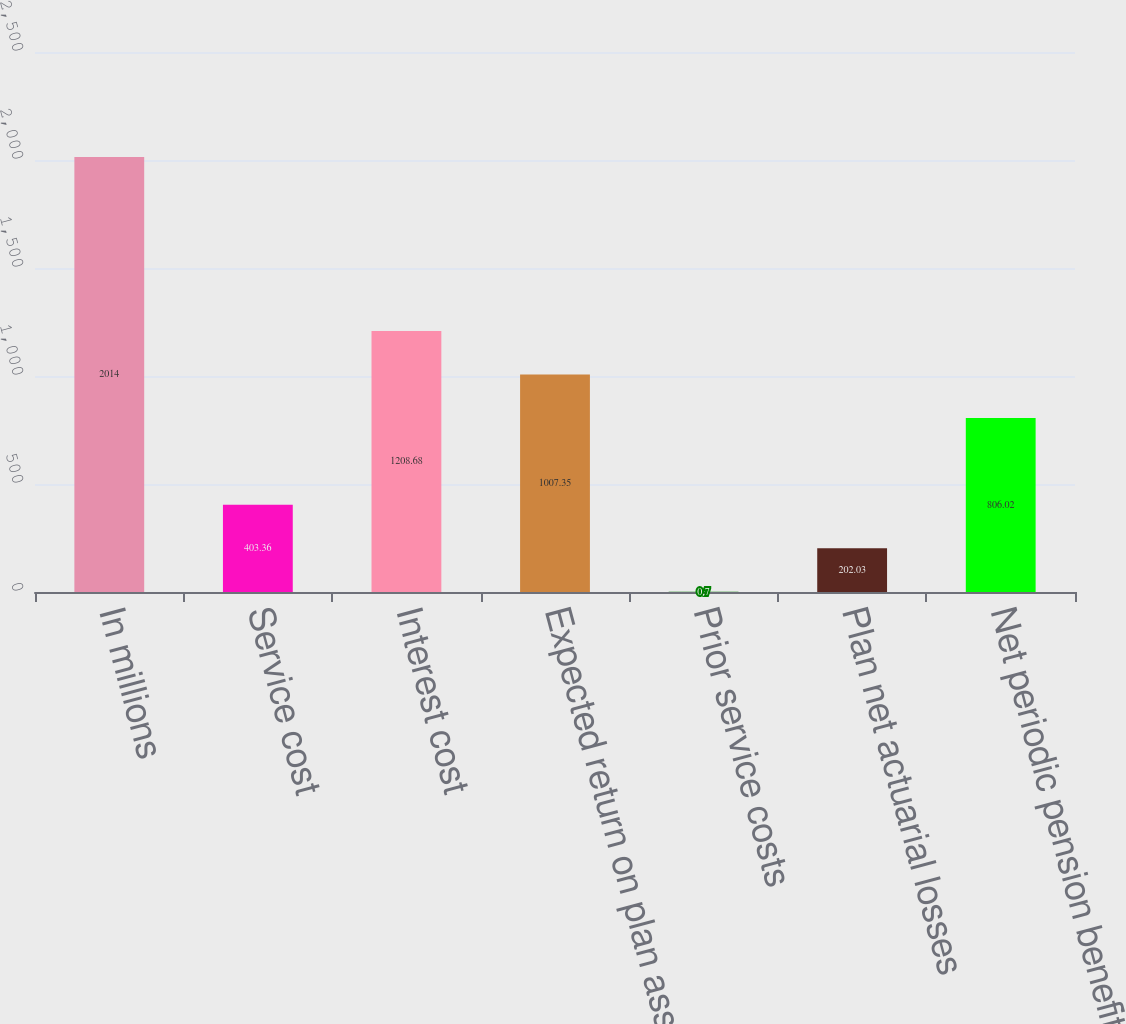<chart> <loc_0><loc_0><loc_500><loc_500><bar_chart><fcel>In millions<fcel>Service cost<fcel>Interest cost<fcel>Expected return on plan assets<fcel>Prior service costs<fcel>Plan net actuarial losses<fcel>Net periodic pension benefit<nl><fcel>2014<fcel>403.36<fcel>1208.68<fcel>1007.35<fcel>0.7<fcel>202.03<fcel>806.02<nl></chart> 